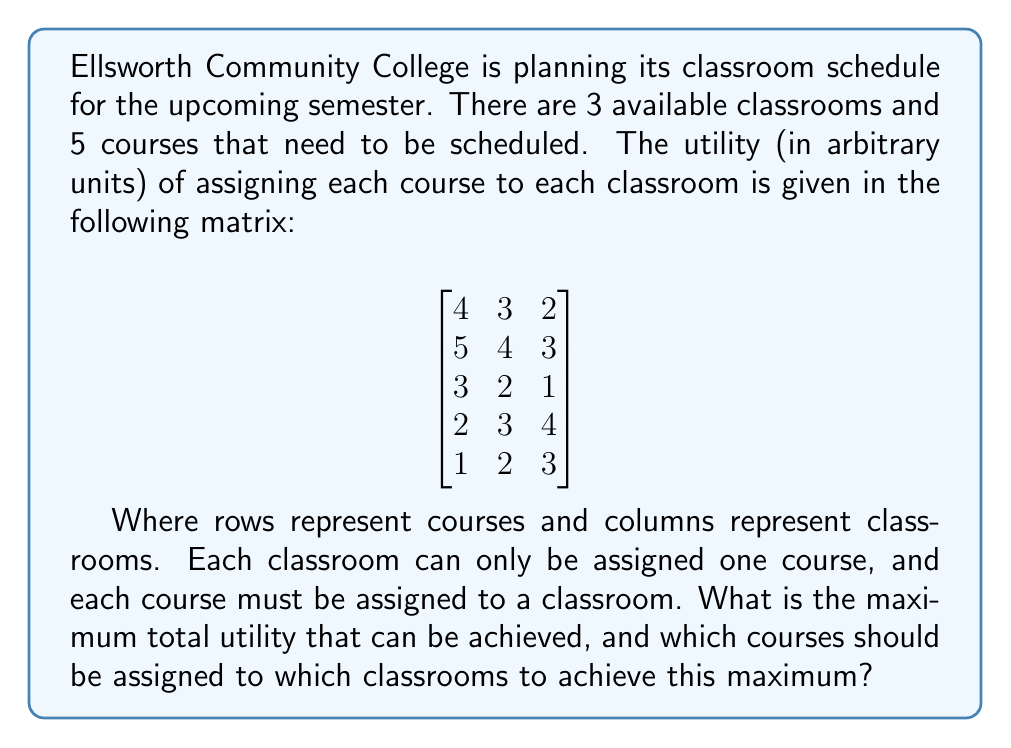Help me with this question. This problem can be solved using the Hungarian algorithm for the assignment problem. However, we'll solve it step-by-step using a simpler method for this 3x3 case:

1) First, we need to reduce this to a 3x3 problem by selecting the three courses that will yield the maximum utility. We can do this by trying all combinations of 3 courses out of 5.

2) The possible combinations are:
   (1,2,3), (1,2,4), (1,2,5), (1,3,4), (1,3,5), (1,4,5), (2,3,4), (2,3,5), (2,4,5), (3,4,5)

3) For each combination, we'll calculate the maximum possible utility:

   (1,2,3): 
   $$\begin{bmatrix}
   4 & 3 & 2 \\
   5 & 4 & 3 \\
   3 & 2 & 1
   \end{bmatrix}$$
   Max = 5 + 3 + 1 = 9

   (1,2,4):
   $$\begin{bmatrix}
   4 & 3 & 2 \\
   5 & 4 & 3 \\
   2 & 3 & 4
   \end{bmatrix}$$
   Max = 5 + 3 + 4 = 12

   (1,2,5):
   $$\begin{bmatrix}
   4 & 3 & 2 \\
   5 & 4 & 3 \\
   1 & 2 & 3
   \end{bmatrix}$$
   Max = 5 + 3 + 3 = 11

   (1,3,4):
   $$\begin{bmatrix}
   4 & 3 & 2 \\
   3 & 2 & 1 \\
   2 & 3 & 4
   \end{bmatrix}$$
   Max = 4 + 3 + 4 = 11

   (1,3,5):
   $$\begin{bmatrix}
   4 & 3 & 2 \\
   3 & 2 & 1 \\
   1 & 2 & 3
   \end{bmatrix}$$
   Max = 4 + 2 + 3 = 9

   (1,4,5):
   $$\begin{bmatrix}
   4 & 3 & 2 \\
   2 & 3 & 4 \\
   1 & 2 & 3
   \end{bmatrix}$$
   Max = 4 + 3 + 3 = 10

   (2,3,4):
   $$\begin{bmatrix}
   5 & 4 & 3 \\
   3 & 2 & 1 \\
   2 & 3 & 4
   \end{bmatrix}$$
   Max = 5 + 3 + 4 = 12

   (2,3,5):
   $$\begin{bmatrix}
   5 & 4 & 3 \\
   3 & 2 & 1 \\
   1 & 2 & 3
   \end{bmatrix}$$
   Max = 5 + 2 + 3 = 10

   (2,4,5):
   $$\begin{bmatrix}
   5 & 4 & 3 \\
   2 & 3 & 4 \\
   1 & 2 & 3
   \end{bmatrix}$$
   Max = 5 + 3 + 3 = 11

   (3,4,5):
   $$\begin{bmatrix}
   3 & 2 & 1 \\
   2 & 3 & 4 \\
   1 & 2 & 3
   \end{bmatrix}$$
   Max = 3 + 3 + 3 = 9

4) The maximum utility is 12, which can be achieved by two combinations: (1,2,4) and (2,3,4).

5) For (1,2,4):
   Course 2 should be assigned to Classroom 1 (utility 5)
   Course 1 should be assigned to Classroom 2 (utility 3)
   Course 4 should be assigned to Classroom 3 (utility 4)

   For (2,3,4):
   Course 2 should be assigned to Classroom 1 (utility 5)
   Course 4 should be assigned to Classroom 2 (utility 3)
   Course 3 should be assigned to Classroom 3 (utility 4)
Answer: The maximum total utility that can be achieved is 12. This can be achieved in two ways:
1) Assign Course 2 to Classroom 1, Course 1 to Classroom 2, and Course 4 to Classroom 3.
2) Assign Course 2 to Classroom 1, Course 4 to Classroom 2, and Course 3 to Classroom 3. 